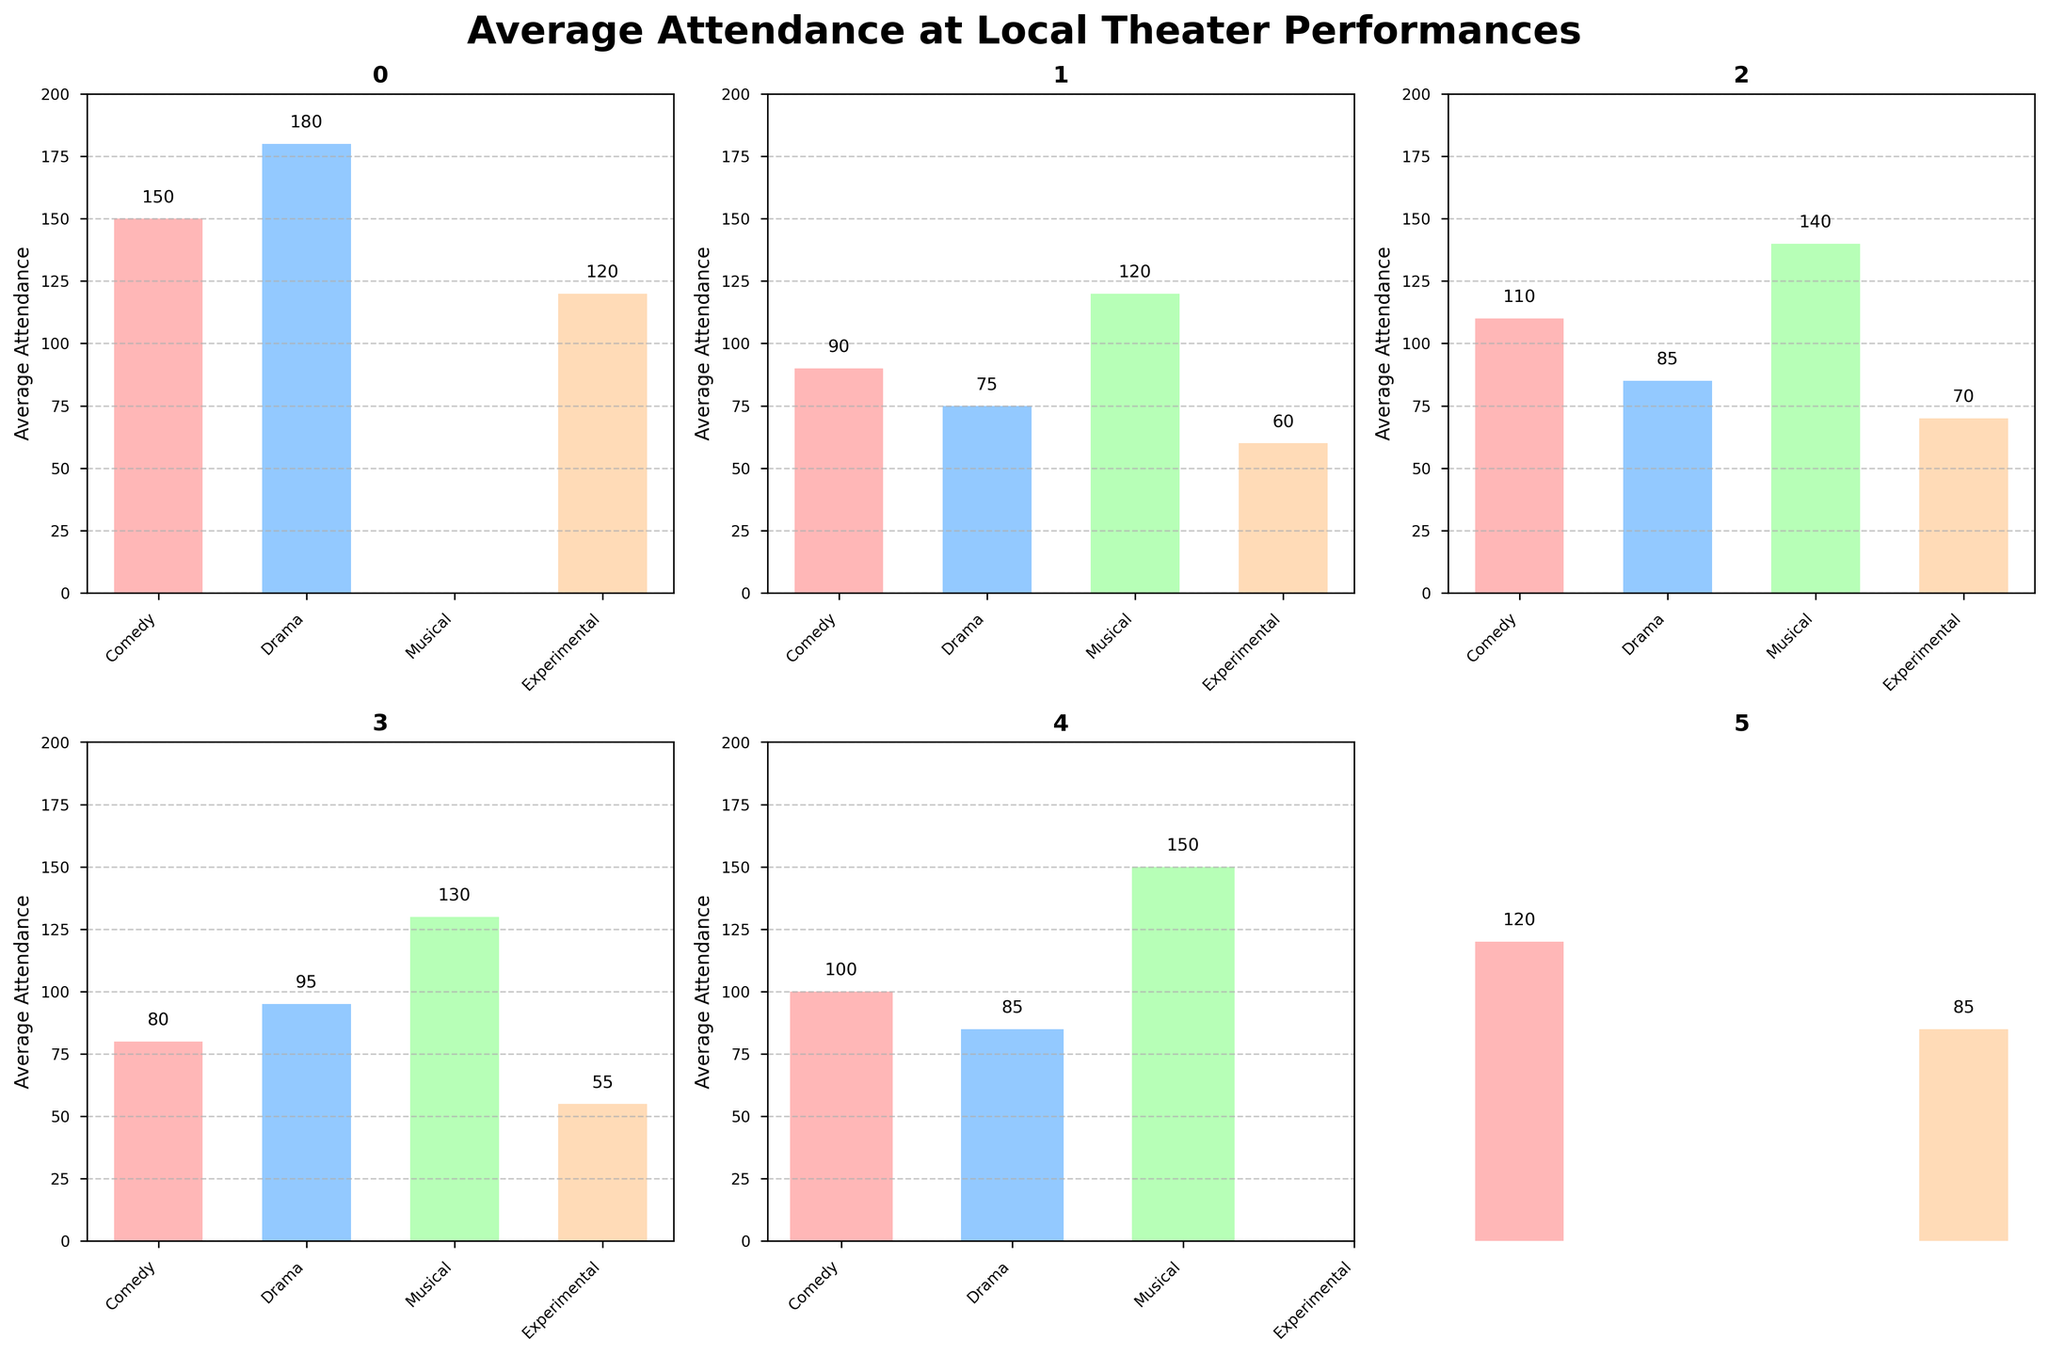What is the average attendance for Comedy performances at "Shakespeare in the Park"? Look at the bar corresponding to Comedy in the subplot titled "Shakespeare in the Park." The bar height represents the average attendance.
Answer: 150 Which venue has the highest average attendance for Musical performances? Compare the heights of the bars representing Musical performances across each subplot that contains Musical data. "Dinner Theater" has the highest bar for Musical performances.
Answer: Dinner Theater How many venues have higher average attendance for Comedy compared to Drama? Observe the heights of the bars for Comedy and Drama in each subplot. "Shakespeare in the Park," "Community Theater," "Children's Theater," and "Dinner Theater" have higher average attendance for Comedy compared to Drama.
Answer: 4 What is the difference in average attendance between "Children's Theater" and "Community Theater" for Experimental performances? Subtract the height of the Experimental bar for "Community Theater" from the Experimental bar for "Children's Theater" (70 - 60).
Answer: 10 Which genre has the lowest attendance in "University Productions"? In the subplot titled "University Productions," find the genre with the shortest bar. The shortest bar represents Experimental performances.
Answer: Experimental What is the average of the highest attendance figures for each venue? Find the highest bar in each subplot, sum these values (180, 120, 140, 130, 150, 120), and divide by the number of venues (6) to get the average (840 / 6).
Answer: 140 Does any venue lack data for Drama performances? Look at the bars for Drama in each subplot to see if any are missing. "Improv Shows" lacks a Drama bar.
Answer: Improv Shows For "Shakespeare in the Park," how does the average attendance for Comedy compare to Experimental? Comparing the heights of the bars for Comedy and Experimental, Comedy (150) is higher than Experimental (120).
Answer: Comedy is higher What is the total average attendance for Experimental performances across all venues? Sum the heights of the Experimental bars in each subplot (120 + 60 + 70 + 55 + 85) and exclude "Dinner Theater" since it lacks data, then get the sum (390).
Answer: 390 What is the highest recorded average attendance across all venues and genres? Identify the tallest bar in all subplots. The highest recorded average attendance is for Drama at "Shakespeare in the Park" (180).
Answer: 180 